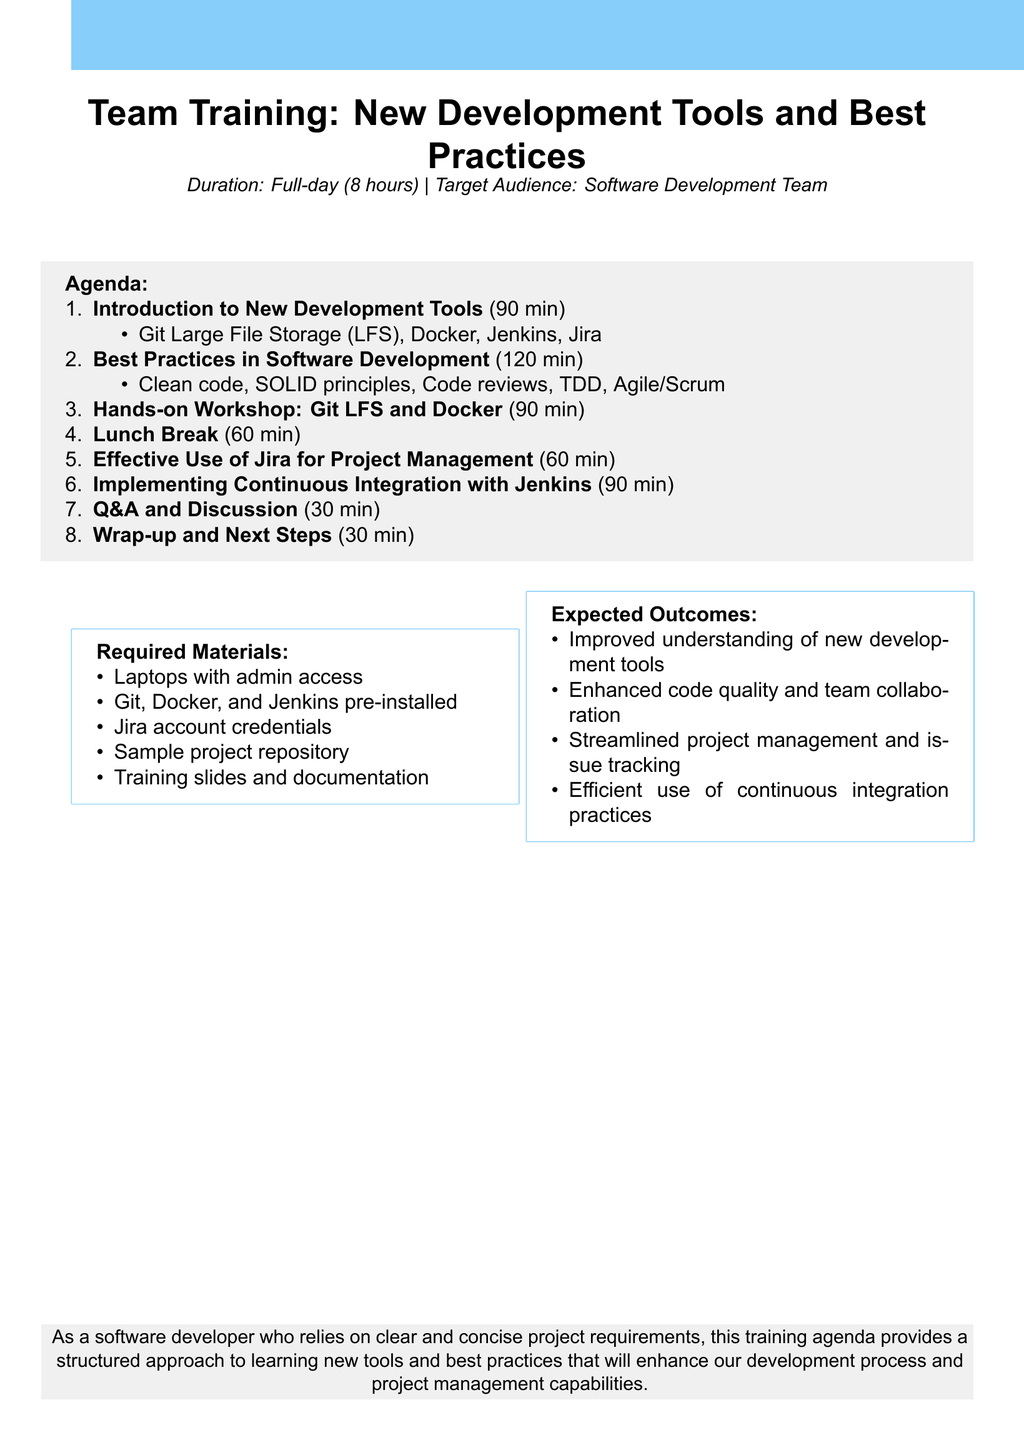What is the total duration of the training? The total duration is specified at the beginning of the agenda as a full-day training session lasting 8 hours.
Answer: 8 hours What is the duration of the "Best Practices in Software Development" section? The duration for this section is listed in the agenda, showing it takes 120 minutes.
Answer: 120 minutes What are the required materials for the training? The document lists materials needed for the training, such as laptops with admin access and Jira account credentials.
Answer: Laptops with admin access, Git, Docker, and Jenkins pre-installed, Jira account credentials, Sample project repository, Training slides and documentation What is one expected outcome of the training? The document specifies outcomes expected from the training, one of which is improved understanding of new development tools.
Answer: Improved understanding of new development tools How long is the lunch break? The lunch break duration is specified in the agenda. It is clearly mentioned as 60 minutes.
Answer: 60 minutes What section comes after the "Hands-on Workshop: Git LFS and Docker"? The agenda outlines the sequence of sections, indicating what follows after the workshop. The next section is the lunch break.
Answer: Lunch Break What is the focus of the final section titled "Wrap-up and Next Steps"? The last section of the agenda details what will be discussed in the wrap-up, which includes a recap of key takeaways.
Answer: Recap of key takeaways How long is the Q&A and Discussion section? The duration of the Q&A section is stated in the agenda, specifying it lasts for 30 minutes.
Answer: 30 minutes What is the target audience for the training? The document specifies who the training is intended for, which is the software development team.
Answer: Software Development Team 